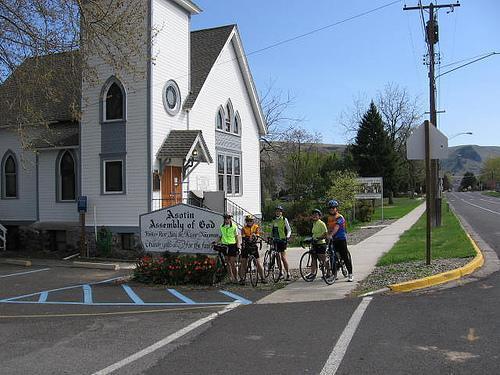How many horses are eating grass?
Give a very brief answer. 0. 